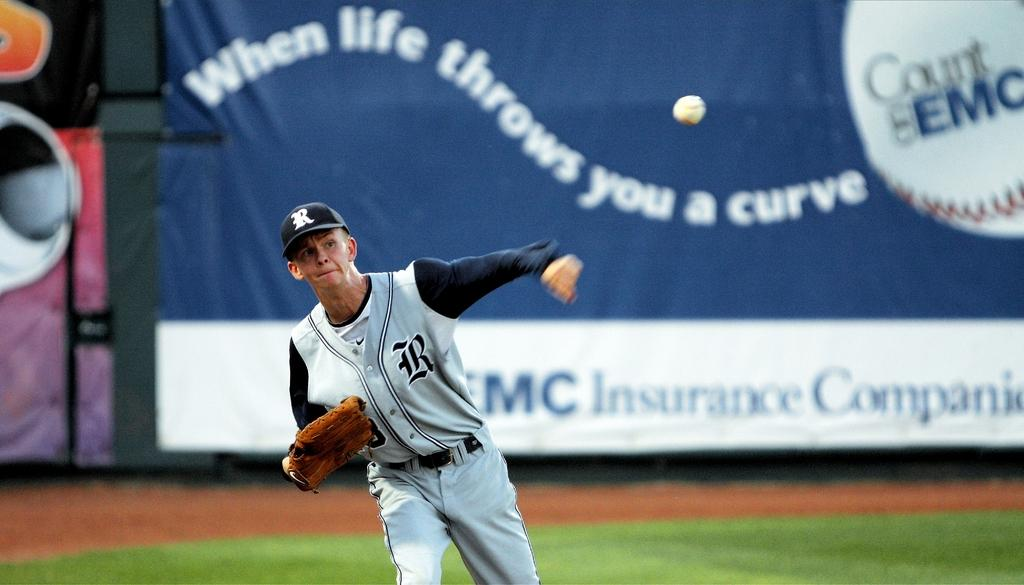Provide a one-sentence caption for the provided image. A baseball player, whose hat is adorned with the letter R, throws a ball. 